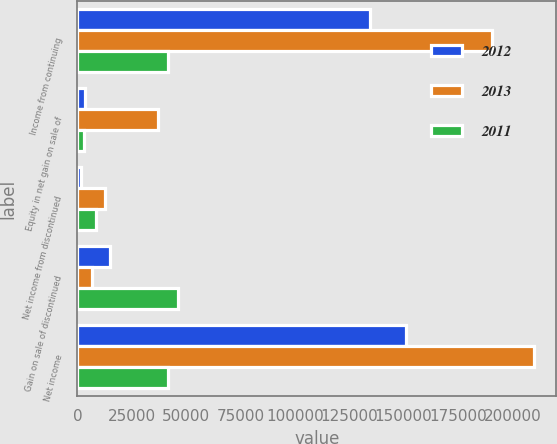<chart> <loc_0><loc_0><loc_500><loc_500><stacked_bar_chart><ecel><fcel>Income from continuing<fcel>Equity in net gain on sale of<fcel>Net income from discontinued<fcel>Gain on sale of discontinued<fcel>Net income<nl><fcel>2012<fcel>134658<fcel>3601<fcel>1725<fcel>14900<fcel>151283<nl><fcel>2013<fcel>190454<fcel>37053<fcel>12619<fcel>6627<fcel>209700<nl><fcel>2011<fcel>41569<fcel>2918<fcel>8560<fcel>46085<fcel>41569<nl></chart> 